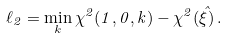Convert formula to latex. <formula><loc_0><loc_0><loc_500><loc_500>\ell _ { 2 } = \min _ { k } \chi ^ { 2 } ( 1 , 0 , k ) - \chi ^ { 2 } ( \hat { \xi } ) \, .</formula> 